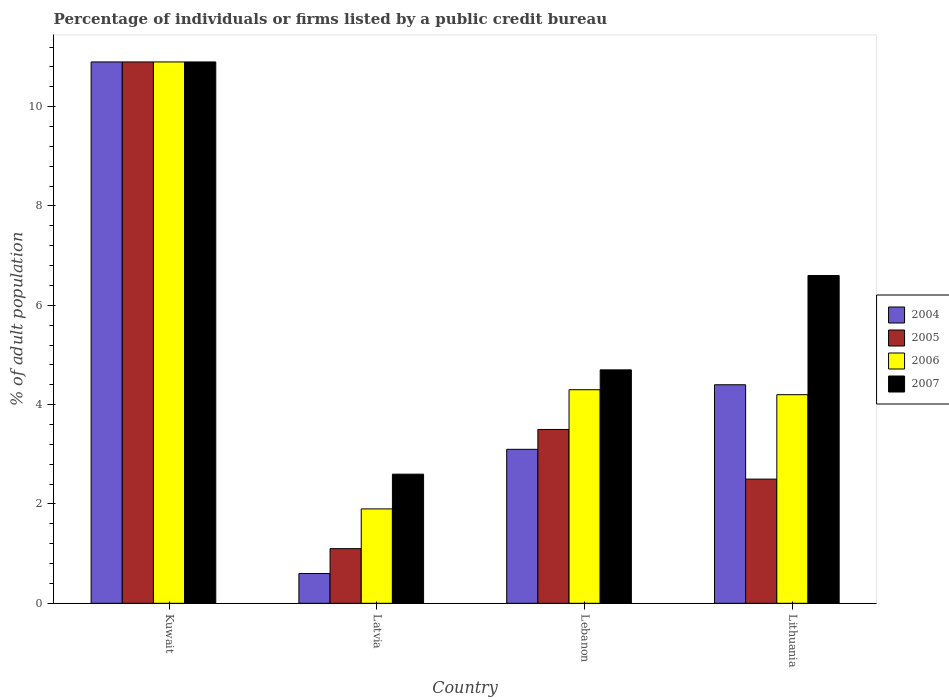How many different coloured bars are there?
Give a very brief answer. 4. Are the number of bars per tick equal to the number of legend labels?
Provide a short and direct response. Yes. How many bars are there on the 2nd tick from the left?
Give a very brief answer. 4. What is the label of the 3rd group of bars from the left?
Offer a very short reply. Lebanon. In how many cases, is the number of bars for a given country not equal to the number of legend labels?
Offer a terse response. 0. What is the percentage of population listed by a public credit bureau in 2006 in Lithuania?
Provide a succinct answer. 4.2. Across all countries, what is the minimum percentage of population listed by a public credit bureau in 2006?
Provide a short and direct response. 1.9. In which country was the percentage of population listed by a public credit bureau in 2004 maximum?
Give a very brief answer. Kuwait. In which country was the percentage of population listed by a public credit bureau in 2004 minimum?
Ensure brevity in your answer.  Latvia. What is the total percentage of population listed by a public credit bureau in 2007 in the graph?
Ensure brevity in your answer.  24.8. What is the difference between the percentage of population listed by a public credit bureau in 2005 in Latvia and the percentage of population listed by a public credit bureau in 2007 in Lithuania?
Offer a terse response. -5.5. What is the average percentage of population listed by a public credit bureau in 2006 per country?
Ensure brevity in your answer.  5.33. What is the difference between the percentage of population listed by a public credit bureau of/in 2004 and percentage of population listed by a public credit bureau of/in 2007 in Lithuania?
Give a very brief answer. -2.2. What is the ratio of the percentage of population listed by a public credit bureau in 2004 in Latvia to that in Lebanon?
Your response must be concise. 0.19. Is the difference between the percentage of population listed by a public credit bureau in 2004 in Lebanon and Lithuania greater than the difference between the percentage of population listed by a public credit bureau in 2007 in Lebanon and Lithuania?
Make the answer very short. Yes. What is the difference between the highest and the second highest percentage of population listed by a public credit bureau in 2005?
Offer a terse response. -8.4. What is the difference between the highest and the lowest percentage of population listed by a public credit bureau in 2005?
Provide a succinct answer. 9.8. Is it the case that in every country, the sum of the percentage of population listed by a public credit bureau in 2005 and percentage of population listed by a public credit bureau in 2007 is greater than the sum of percentage of population listed by a public credit bureau in 2004 and percentage of population listed by a public credit bureau in 2006?
Your response must be concise. No. What does the 2nd bar from the right in Lithuania represents?
Your answer should be compact. 2006. Is it the case that in every country, the sum of the percentage of population listed by a public credit bureau in 2005 and percentage of population listed by a public credit bureau in 2006 is greater than the percentage of population listed by a public credit bureau in 2007?
Your response must be concise. Yes. How many bars are there?
Provide a short and direct response. 16. Are all the bars in the graph horizontal?
Offer a terse response. No. How many countries are there in the graph?
Offer a very short reply. 4. What is the difference between two consecutive major ticks on the Y-axis?
Provide a short and direct response. 2. Does the graph contain any zero values?
Your response must be concise. No. Does the graph contain grids?
Your answer should be very brief. No. Where does the legend appear in the graph?
Offer a very short reply. Center right. How many legend labels are there?
Keep it short and to the point. 4. How are the legend labels stacked?
Your answer should be compact. Vertical. What is the title of the graph?
Keep it short and to the point. Percentage of individuals or firms listed by a public credit bureau. Does "1963" appear as one of the legend labels in the graph?
Offer a terse response. No. What is the label or title of the X-axis?
Offer a terse response. Country. What is the label or title of the Y-axis?
Offer a terse response. % of adult population. What is the % of adult population of 2007 in Latvia?
Ensure brevity in your answer.  2.6. What is the % of adult population in 2004 in Lithuania?
Offer a terse response. 4.4. What is the % of adult population of 2007 in Lithuania?
Ensure brevity in your answer.  6.6. Across all countries, what is the maximum % of adult population of 2007?
Keep it short and to the point. 10.9. Across all countries, what is the minimum % of adult population in 2004?
Provide a succinct answer. 0.6. Across all countries, what is the minimum % of adult population in 2005?
Provide a succinct answer. 1.1. Across all countries, what is the minimum % of adult population in 2007?
Keep it short and to the point. 2.6. What is the total % of adult population of 2006 in the graph?
Make the answer very short. 21.3. What is the total % of adult population in 2007 in the graph?
Give a very brief answer. 24.8. What is the difference between the % of adult population of 2004 in Kuwait and that in Latvia?
Provide a succinct answer. 10.3. What is the difference between the % of adult population in 2005 in Kuwait and that in Latvia?
Provide a short and direct response. 9.8. What is the difference between the % of adult population in 2006 in Kuwait and that in Latvia?
Your response must be concise. 9. What is the difference between the % of adult population of 2007 in Kuwait and that in Latvia?
Your answer should be very brief. 8.3. What is the difference between the % of adult population in 2004 in Kuwait and that in Lebanon?
Your answer should be very brief. 7.8. What is the difference between the % of adult population in 2005 in Kuwait and that in Lebanon?
Provide a short and direct response. 7.4. What is the difference between the % of adult population of 2007 in Kuwait and that in Lebanon?
Provide a short and direct response. 6.2. What is the difference between the % of adult population in 2004 in Kuwait and that in Lithuania?
Make the answer very short. 6.5. What is the difference between the % of adult population in 2005 in Kuwait and that in Lithuania?
Make the answer very short. 8.4. What is the difference between the % of adult population of 2007 in Kuwait and that in Lithuania?
Provide a short and direct response. 4.3. What is the difference between the % of adult population in 2004 in Latvia and that in Lebanon?
Your answer should be very brief. -2.5. What is the difference between the % of adult population in 2007 in Latvia and that in Lebanon?
Your response must be concise. -2.1. What is the difference between the % of adult population in 2004 in Latvia and that in Lithuania?
Offer a terse response. -3.8. What is the difference between the % of adult population of 2005 in Latvia and that in Lithuania?
Your answer should be very brief. -1.4. What is the difference between the % of adult population in 2007 in Latvia and that in Lithuania?
Keep it short and to the point. -4. What is the difference between the % of adult population of 2006 in Lebanon and that in Lithuania?
Your answer should be very brief. 0.1. What is the difference between the % of adult population in 2007 in Lebanon and that in Lithuania?
Provide a short and direct response. -1.9. What is the difference between the % of adult population in 2005 in Kuwait and the % of adult population in 2007 in Latvia?
Give a very brief answer. 8.3. What is the difference between the % of adult population of 2006 in Kuwait and the % of adult population of 2007 in Latvia?
Offer a terse response. 8.3. What is the difference between the % of adult population in 2004 in Kuwait and the % of adult population in 2005 in Lebanon?
Your answer should be compact. 7.4. What is the difference between the % of adult population in 2005 in Kuwait and the % of adult population in 2007 in Lebanon?
Your response must be concise. 6.2. What is the difference between the % of adult population in 2004 in Kuwait and the % of adult population in 2005 in Lithuania?
Give a very brief answer. 8.4. What is the difference between the % of adult population of 2004 in Kuwait and the % of adult population of 2006 in Lithuania?
Your response must be concise. 6.7. What is the difference between the % of adult population in 2004 in Kuwait and the % of adult population in 2007 in Lithuania?
Ensure brevity in your answer.  4.3. What is the difference between the % of adult population in 2006 in Kuwait and the % of adult population in 2007 in Lithuania?
Make the answer very short. 4.3. What is the difference between the % of adult population in 2004 in Latvia and the % of adult population in 2005 in Lebanon?
Your answer should be very brief. -2.9. What is the difference between the % of adult population in 2004 in Latvia and the % of adult population in 2007 in Lithuania?
Ensure brevity in your answer.  -6. What is the difference between the % of adult population of 2005 in Latvia and the % of adult population of 2006 in Lithuania?
Keep it short and to the point. -3.1. What is the difference between the % of adult population of 2005 in Latvia and the % of adult population of 2007 in Lithuania?
Your answer should be very brief. -5.5. What is the difference between the % of adult population in 2004 in Lebanon and the % of adult population in 2006 in Lithuania?
Your answer should be compact. -1.1. What is the difference between the % of adult population of 2004 in Lebanon and the % of adult population of 2007 in Lithuania?
Make the answer very short. -3.5. What is the difference between the % of adult population of 2006 in Lebanon and the % of adult population of 2007 in Lithuania?
Provide a succinct answer. -2.3. What is the average % of adult population of 2004 per country?
Your answer should be very brief. 4.75. What is the average % of adult population of 2006 per country?
Your answer should be very brief. 5.33. What is the difference between the % of adult population of 2004 and % of adult population of 2005 in Kuwait?
Keep it short and to the point. 0. What is the difference between the % of adult population of 2004 and % of adult population of 2006 in Kuwait?
Offer a very short reply. 0. What is the difference between the % of adult population of 2005 and % of adult population of 2006 in Kuwait?
Your response must be concise. 0. What is the difference between the % of adult population in 2005 and % of adult population in 2007 in Latvia?
Offer a terse response. -1.5. What is the difference between the % of adult population in 2004 and % of adult population in 2005 in Lebanon?
Make the answer very short. -0.4. What is the difference between the % of adult population in 2005 and % of adult population in 2006 in Lebanon?
Offer a very short reply. -0.8. What is the difference between the % of adult population in 2005 and % of adult population in 2007 in Lebanon?
Ensure brevity in your answer.  -1.2. What is the difference between the % of adult population of 2006 and % of adult population of 2007 in Lebanon?
Provide a succinct answer. -0.4. What is the difference between the % of adult population in 2004 and % of adult population in 2007 in Lithuania?
Keep it short and to the point. -2.2. What is the difference between the % of adult population of 2005 and % of adult population of 2006 in Lithuania?
Provide a succinct answer. -1.7. What is the ratio of the % of adult population in 2004 in Kuwait to that in Latvia?
Ensure brevity in your answer.  18.17. What is the ratio of the % of adult population in 2005 in Kuwait to that in Latvia?
Give a very brief answer. 9.91. What is the ratio of the % of adult population in 2006 in Kuwait to that in Latvia?
Your answer should be compact. 5.74. What is the ratio of the % of adult population of 2007 in Kuwait to that in Latvia?
Offer a terse response. 4.19. What is the ratio of the % of adult population of 2004 in Kuwait to that in Lebanon?
Keep it short and to the point. 3.52. What is the ratio of the % of adult population of 2005 in Kuwait to that in Lebanon?
Your answer should be compact. 3.11. What is the ratio of the % of adult population in 2006 in Kuwait to that in Lebanon?
Keep it short and to the point. 2.53. What is the ratio of the % of adult population in 2007 in Kuwait to that in Lebanon?
Offer a very short reply. 2.32. What is the ratio of the % of adult population in 2004 in Kuwait to that in Lithuania?
Keep it short and to the point. 2.48. What is the ratio of the % of adult population in 2005 in Kuwait to that in Lithuania?
Offer a very short reply. 4.36. What is the ratio of the % of adult population in 2006 in Kuwait to that in Lithuania?
Provide a short and direct response. 2.6. What is the ratio of the % of adult population of 2007 in Kuwait to that in Lithuania?
Your answer should be compact. 1.65. What is the ratio of the % of adult population of 2004 in Latvia to that in Lebanon?
Give a very brief answer. 0.19. What is the ratio of the % of adult population in 2005 in Latvia to that in Lebanon?
Your answer should be compact. 0.31. What is the ratio of the % of adult population in 2006 in Latvia to that in Lebanon?
Your answer should be compact. 0.44. What is the ratio of the % of adult population in 2007 in Latvia to that in Lebanon?
Make the answer very short. 0.55. What is the ratio of the % of adult population in 2004 in Latvia to that in Lithuania?
Offer a very short reply. 0.14. What is the ratio of the % of adult population of 2005 in Latvia to that in Lithuania?
Your answer should be very brief. 0.44. What is the ratio of the % of adult population of 2006 in Latvia to that in Lithuania?
Your answer should be compact. 0.45. What is the ratio of the % of adult population of 2007 in Latvia to that in Lithuania?
Give a very brief answer. 0.39. What is the ratio of the % of adult population of 2004 in Lebanon to that in Lithuania?
Provide a succinct answer. 0.7. What is the ratio of the % of adult population in 2006 in Lebanon to that in Lithuania?
Keep it short and to the point. 1.02. What is the ratio of the % of adult population of 2007 in Lebanon to that in Lithuania?
Make the answer very short. 0.71. What is the difference between the highest and the second highest % of adult population in 2005?
Give a very brief answer. 7.4. What is the difference between the highest and the second highest % of adult population in 2006?
Your answer should be very brief. 6.6. What is the difference between the highest and the lowest % of adult population of 2004?
Give a very brief answer. 10.3. What is the difference between the highest and the lowest % of adult population of 2006?
Make the answer very short. 9. What is the difference between the highest and the lowest % of adult population of 2007?
Your answer should be compact. 8.3. 